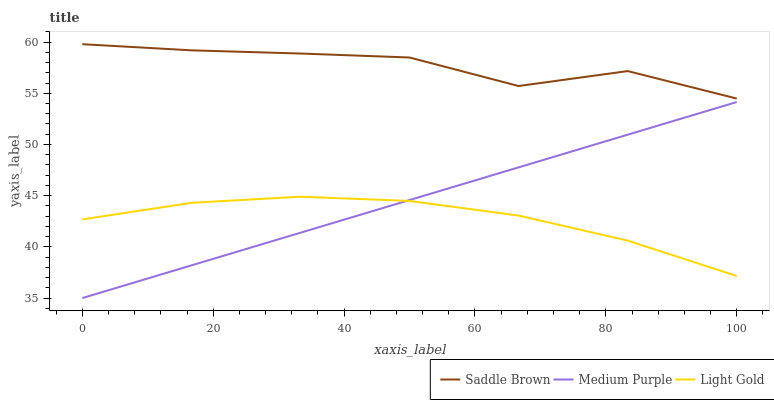Does Light Gold have the minimum area under the curve?
Answer yes or no. Yes. Does Saddle Brown have the maximum area under the curve?
Answer yes or no. Yes. Does Saddle Brown have the minimum area under the curve?
Answer yes or no. No. Does Light Gold have the maximum area under the curve?
Answer yes or no. No. Is Medium Purple the smoothest?
Answer yes or no. Yes. Is Saddle Brown the roughest?
Answer yes or no. Yes. Is Light Gold the smoothest?
Answer yes or no. No. Is Light Gold the roughest?
Answer yes or no. No. Does Medium Purple have the lowest value?
Answer yes or no. Yes. Does Light Gold have the lowest value?
Answer yes or no. No. Does Saddle Brown have the highest value?
Answer yes or no. Yes. Does Light Gold have the highest value?
Answer yes or no. No. Is Medium Purple less than Saddle Brown?
Answer yes or no. Yes. Is Saddle Brown greater than Light Gold?
Answer yes or no. Yes. Does Medium Purple intersect Light Gold?
Answer yes or no. Yes. Is Medium Purple less than Light Gold?
Answer yes or no. No. Is Medium Purple greater than Light Gold?
Answer yes or no. No. Does Medium Purple intersect Saddle Brown?
Answer yes or no. No. 